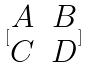<formula> <loc_0><loc_0><loc_500><loc_500>[ \begin{matrix} A & B \\ C & D \end{matrix} ]</formula> 